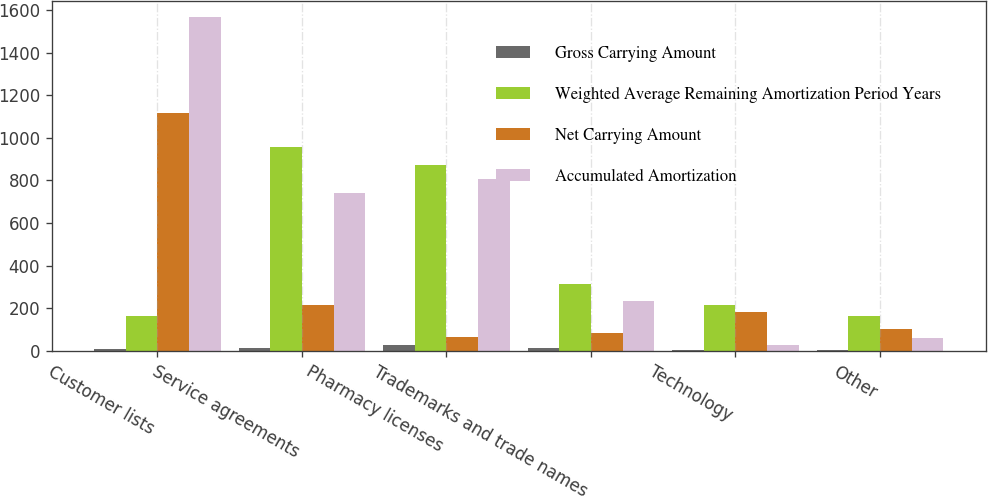Convert chart to OTSL. <chart><loc_0><loc_0><loc_500><loc_500><stacked_bar_chart><ecel><fcel>Customer lists<fcel>Service agreements<fcel>Pharmacy licenses<fcel>Trademarks and trade names<fcel>Technology<fcel>Other<nl><fcel>Gross Carrying Amount<fcel>8<fcel>15<fcel>26<fcel>15<fcel>3<fcel>4<nl><fcel>Weighted Average Remaining Amortization Period Years<fcel>162<fcel>957<fcel>874<fcel>315<fcel>213<fcel>162<nl><fcel>Net Carrying Amount<fcel>1116<fcel>215<fcel>65<fcel>82<fcel>184<fcel>101<nl><fcel>Accumulated Amortization<fcel>1567<fcel>742<fcel>809<fcel>233<fcel>29<fcel>61<nl></chart> 